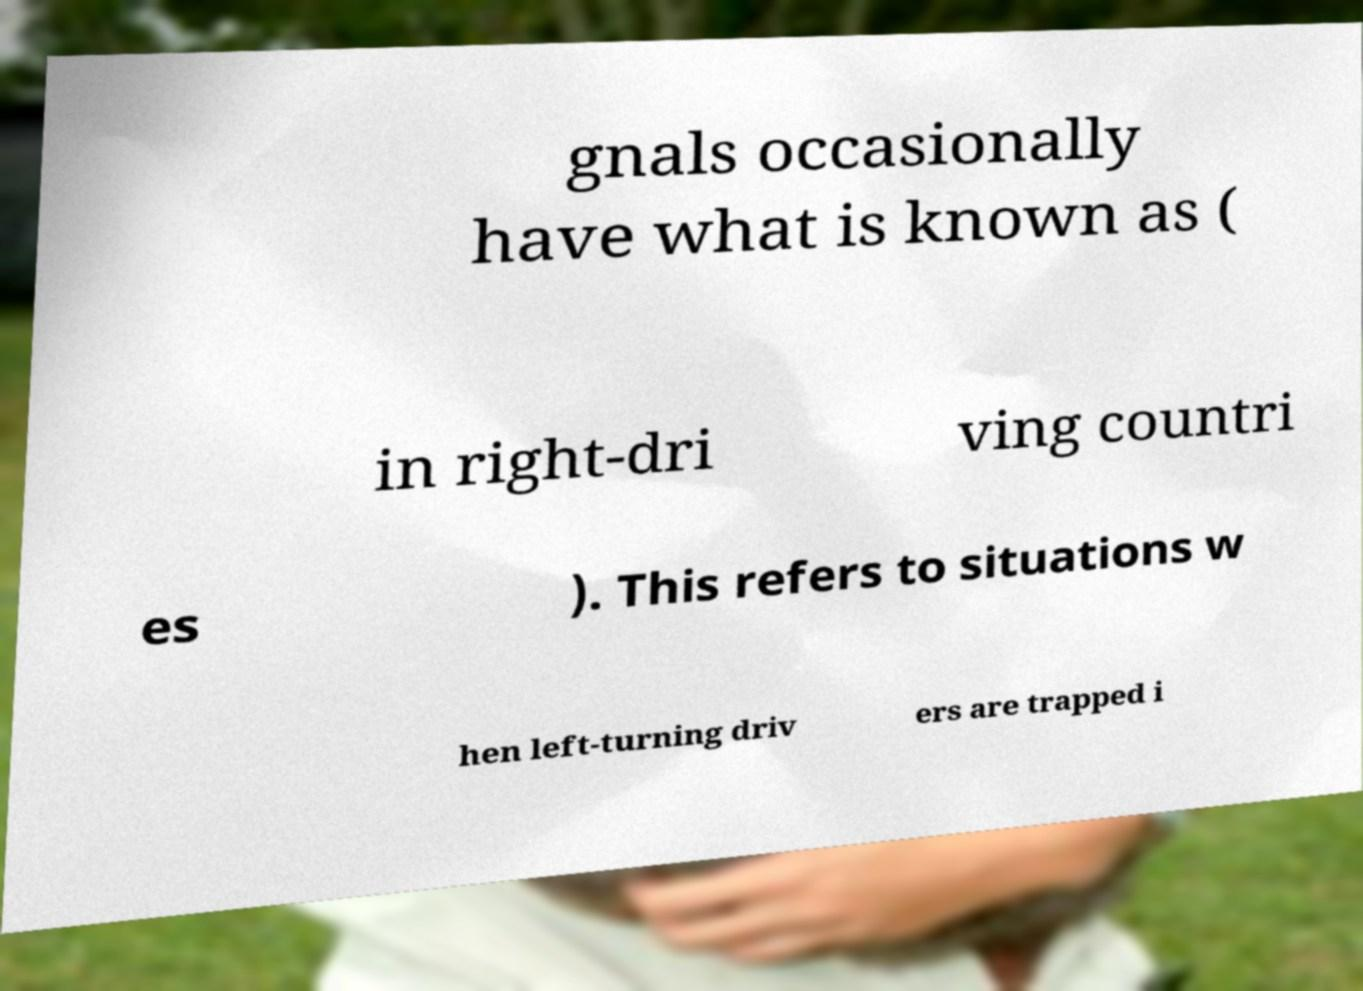There's text embedded in this image that I need extracted. Can you transcribe it verbatim? gnals occasionally have what is known as ( in right-dri ving countri es ). This refers to situations w hen left-turning driv ers are trapped i 